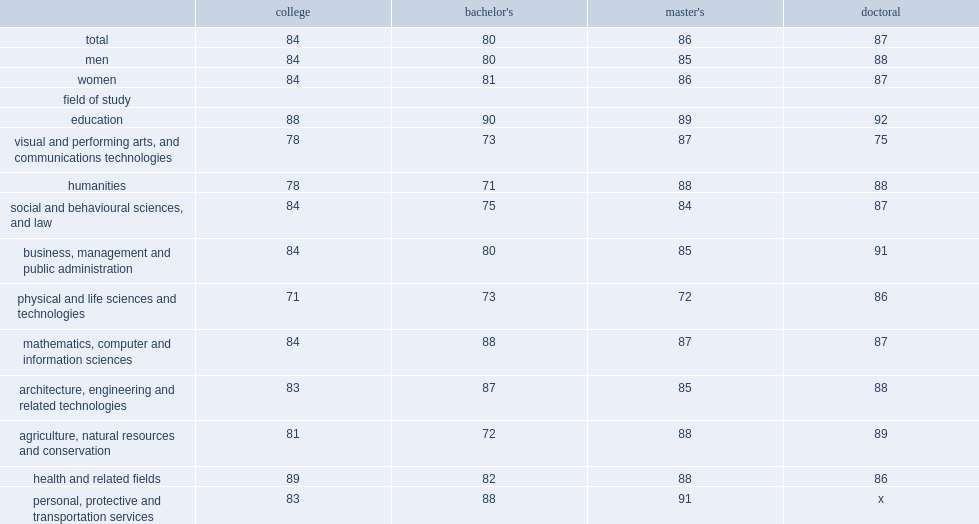What was the percentage of bachelor's graduates in 'humanities'reported lower levels of job satisfaction? 71.0. What was the percentage of doctoral graduates in 'visual and performing arts, and communications technologies' reported lower levels of job satisfaction? 75.0. 